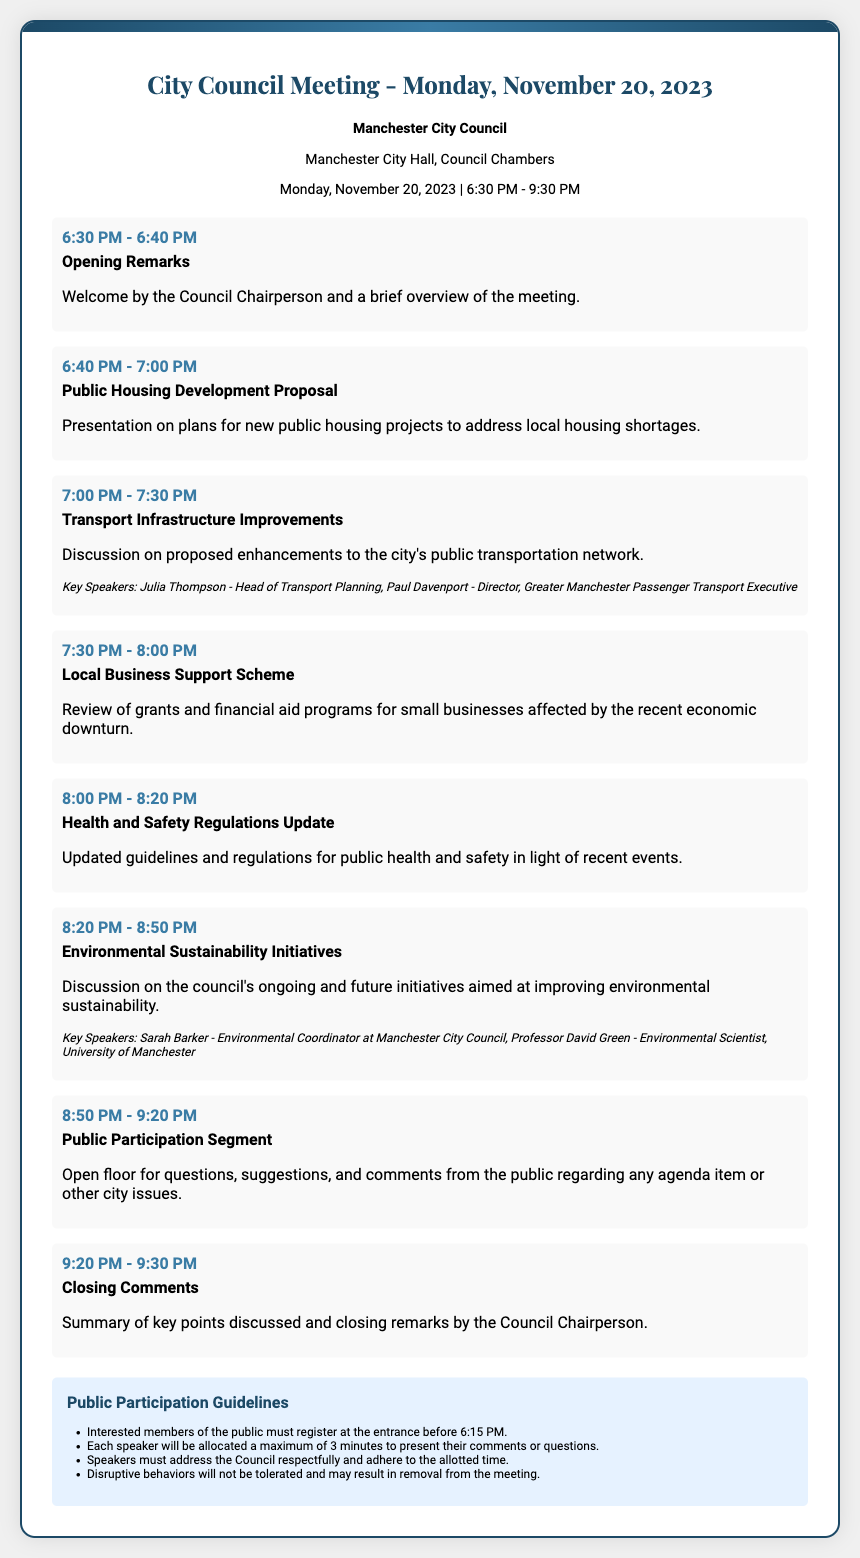What date is the city council meeting scheduled for? The date of the meeting is specified in the document as November 20, 2023.
Answer: November 20, 2023 Who is the Chairperson welcoming the attendees? The document mentions the Chairperson giving opening remarks, but does not specify a name.
Answer: (not specified) What is the time slot for the Public Housing Development Proposal? This agenda item occurs between 6:40 PM and 7:00 PM according to the document.
Answer: 6:40 PM - 7:00 PM What is the title of the speaker for the Transport Infrastructure Improvements discussion? The key speakers for this item are listed, one of which is Julia Thompson, Head of Transport Planning.
Answer: Julia Thompson How long do speakers have to present their comments during the public participation segment? The document states that each speaker is allocated a maximum of 3 minutes.
Answer: 3 minutes Which agenda item discusses Environmental Sustainability Initiatives? The document specifies "Environmental Sustainability Initiatives" as an agenda item occurring at 8:20 PM.
Answer: Environmental Sustainability Initiatives What location is the city council meeting held in? The meeting is stated to take place at "Manchester City Hall, Council Chambers."
Answer: Manchester City Hall, Council Chambers What time does the city council meeting start? The opening time of the meeting is given in the document as 6:30 PM.
Answer: 6:30 PM 